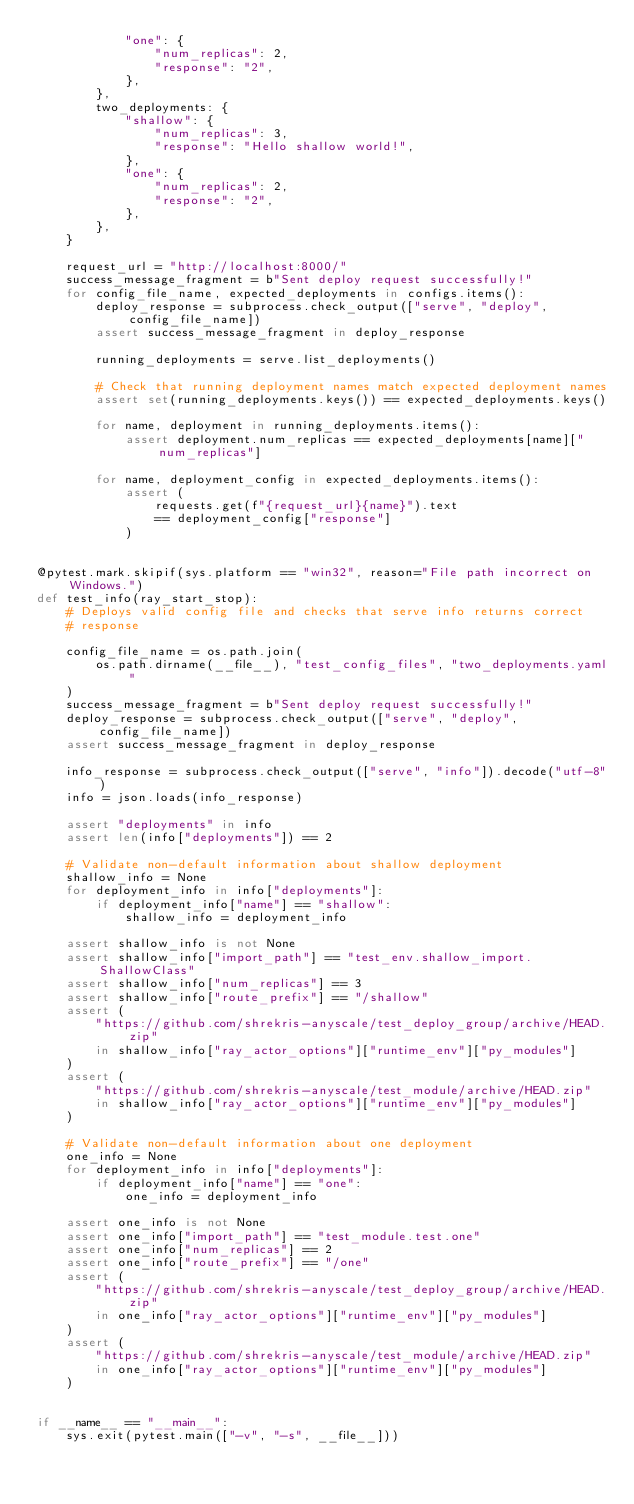Convert code to text. <code><loc_0><loc_0><loc_500><loc_500><_Python_>            "one": {
                "num_replicas": 2,
                "response": "2",
            },
        },
        two_deployments: {
            "shallow": {
                "num_replicas": 3,
                "response": "Hello shallow world!",
            },
            "one": {
                "num_replicas": 2,
                "response": "2",
            },
        },
    }

    request_url = "http://localhost:8000/"
    success_message_fragment = b"Sent deploy request successfully!"
    for config_file_name, expected_deployments in configs.items():
        deploy_response = subprocess.check_output(["serve", "deploy", config_file_name])
        assert success_message_fragment in deploy_response

        running_deployments = serve.list_deployments()

        # Check that running deployment names match expected deployment names
        assert set(running_deployments.keys()) == expected_deployments.keys()

        for name, deployment in running_deployments.items():
            assert deployment.num_replicas == expected_deployments[name]["num_replicas"]

        for name, deployment_config in expected_deployments.items():
            assert (
                requests.get(f"{request_url}{name}").text
                == deployment_config["response"]
            )


@pytest.mark.skipif(sys.platform == "win32", reason="File path incorrect on Windows.")
def test_info(ray_start_stop):
    # Deploys valid config file and checks that serve info returns correct
    # response

    config_file_name = os.path.join(
        os.path.dirname(__file__), "test_config_files", "two_deployments.yaml"
    )
    success_message_fragment = b"Sent deploy request successfully!"
    deploy_response = subprocess.check_output(["serve", "deploy", config_file_name])
    assert success_message_fragment in deploy_response

    info_response = subprocess.check_output(["serve", "info"]).decode("utf-8")
    info = json.loads(info_response)

    assert "deployments" in info
    assert len(info["deployments"]) == 2

    # Validate non-default information about shallow deployment
    shallow_info = None
    for deployment_info in info["deployments"]:
        if deployment_info["name"] == "shallow":
            shallow_info = deployment_info

    assert shallow_info is not None
    assert shallow_info["import_path"] == "test_env.shallow_import.ShallowClass"
    assert shallow_info["num_replicas"] == 3
    assert shallow_info["route_prefix"] == "/shallow"
    assert (
        "https://github.com/shrekris-anyscale/test_deploy_group/archive/HEAD.zip"
        in shallow_info["ray_actor_options"]["runtime_env"]["py_modules"]
    )
    assert (
        "https://github.com/shrekris-anyscale/test_module/archive/HEAD.zip"
        in shallow_info["ray_actor_options"]["runtime_env"]["py_modules"]
    )

    # Validate non-default information about one deployment
    one_info = None
    for deployment_info in info["deployments"]:
        if deployment_info["name"] == "one":
            one_info = deployment_info

    assert one_info is not None
    assert one_info["import_path"] == "test_module.test.one"
    assert one_info["num_replicas"] == 2
    assert one_info["route_prefix"] == "/one"
    assert (
        "https://github.com/shrekris-anyscale/test_deploy_group/archive/HEAD.zip"
        in one_info["ray_actor_options"]["runtime_env"]["py_modules"]
    )
    assert (
        "https://github.com/shrekris-anyscale/test_module/archive/HEAD.zip"
        in one_info["ray_actor_options"]["runtime_env"]["py_modules"]
    )


if __name__ == "__main__":
    sys.exit(pytest.main(["-v", "-s", __file__]))
</code> 